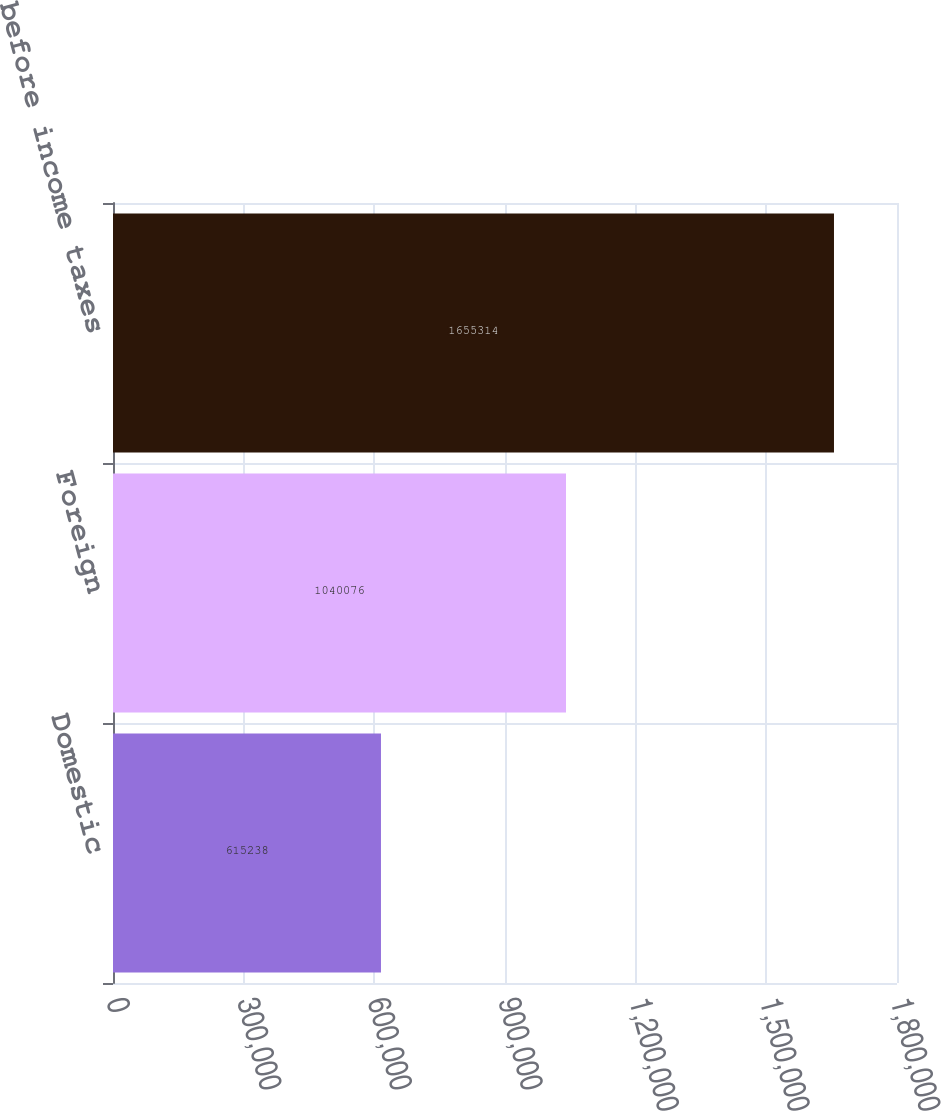Convert chart. <chart><loc_0><loc_0><loc_500><loc_500><bar_chart><fcel>Domestic<fcel>Foreign<fcel>Income before income taxes<nl><fcel>615238<fcel>1.04008e+06<fcel>1.65531e+06<nl></chart> 